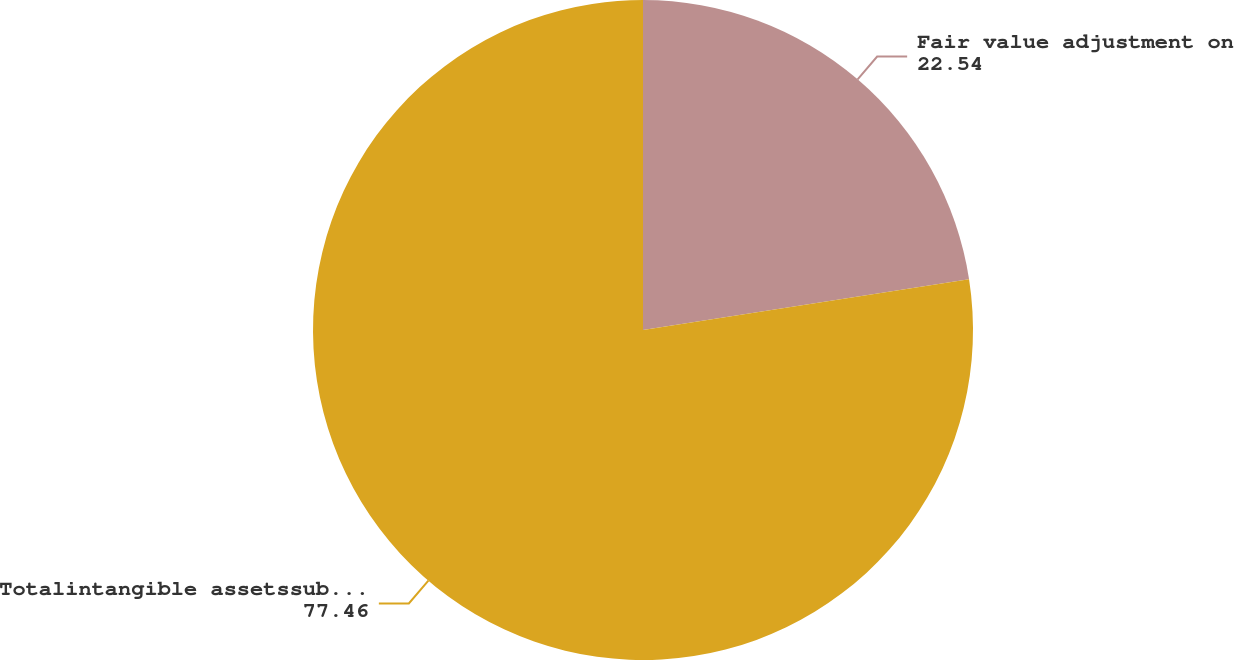Convert chart. <chart><loc_0><loc_0><loc_500><loc_500><pie_chart><fcel>Fair value adjustment on<fcel>Totalintangible assetssubject<nl><fcel>22.54%<fcel>77.46%<nl></chart> 